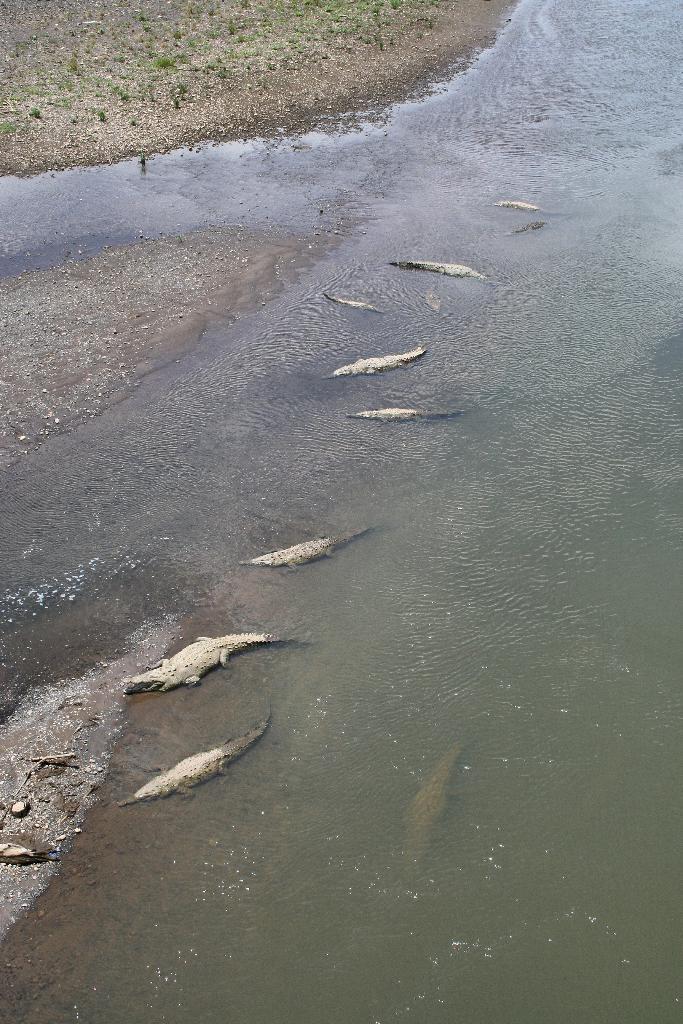Could you give a brief overview of what you see in this image? This picture is clicked outside the city. In the center we can see the reptiles in the water body. In the background we can see the ground and some other items. 